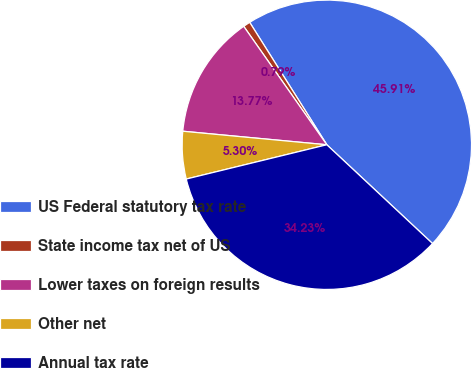Convert chart. <chart><loc_0><loc_0><loc_500><loc_500><pie_chart><fcel>US Federal statutory tax rate<fcel>State income tax net of US<fcel>Lower taxes on foreign results<fcel>Other net<fcel>Annual tax rate<nl><fcel>45.91%<fcel>0.79%<fcel>13.77%<fcel>5.3%<fcel>34.23%<nl></chart> 